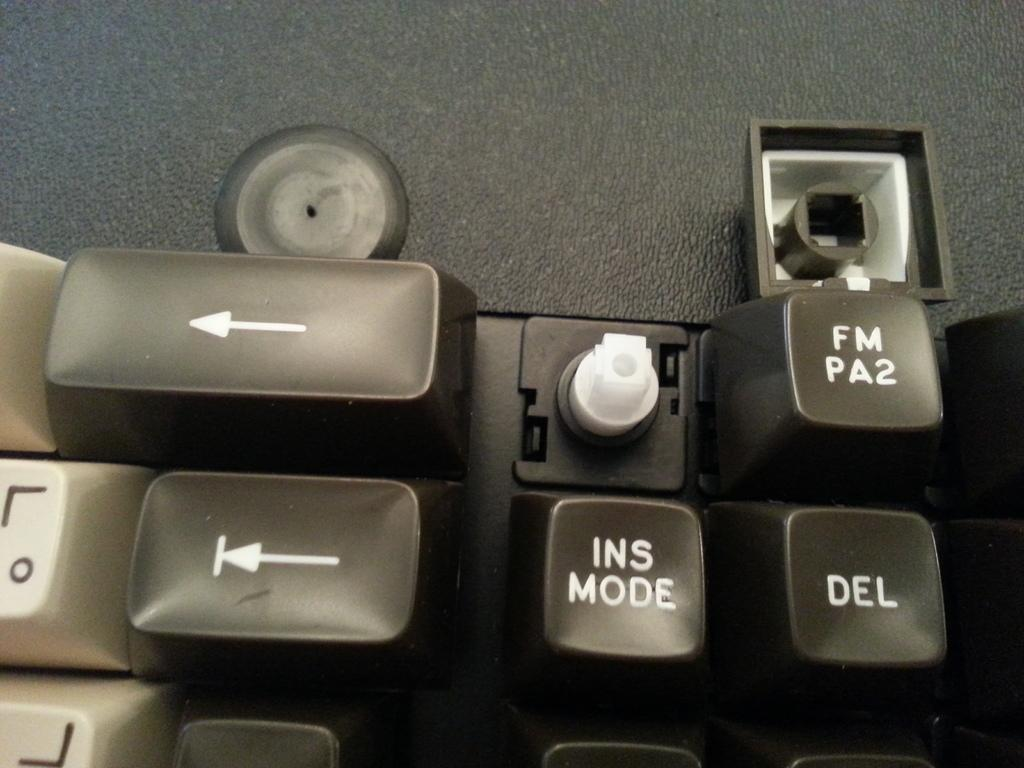Provide a one-sentence caption for the provided image. A close up of a keyboard and a key is broken above the INS MODE key. 